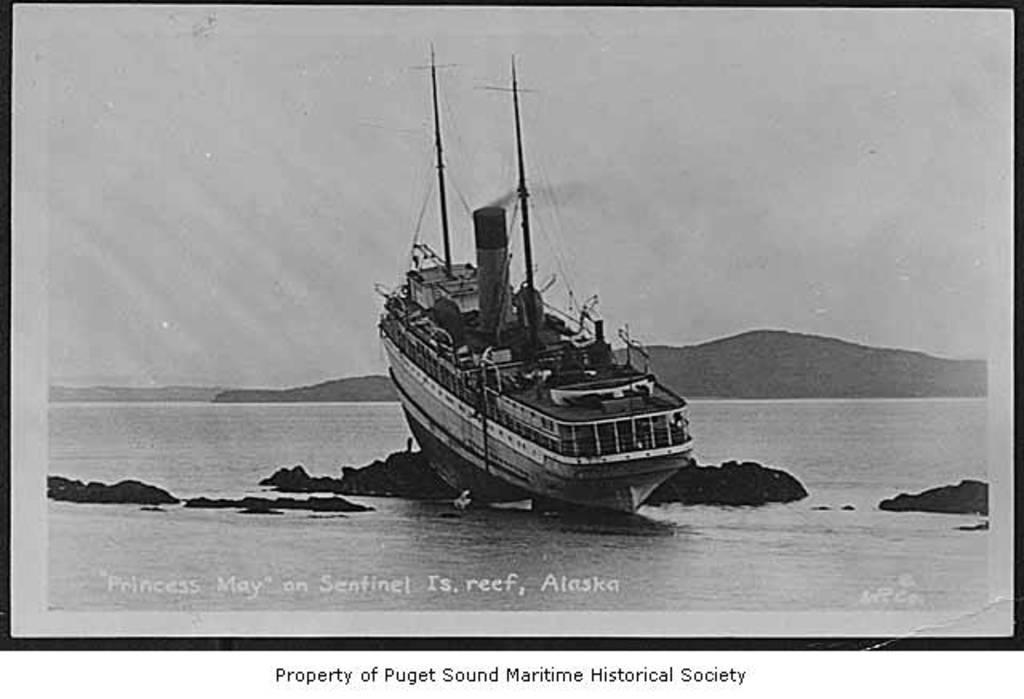What type of image is being described? The image is a photograph. What is the main subject of the photograph? There is a ship in the water. What can be seen in the background of the photograph? Hills and the sky are visible in the background. Is there any text present in the image? Yes, there is text at the bottom of the image. What type of bait is being used by the ship in the image? There is no mention of bait or fishing in the image, as it features a ship in the water with hills and the sky in the background. 